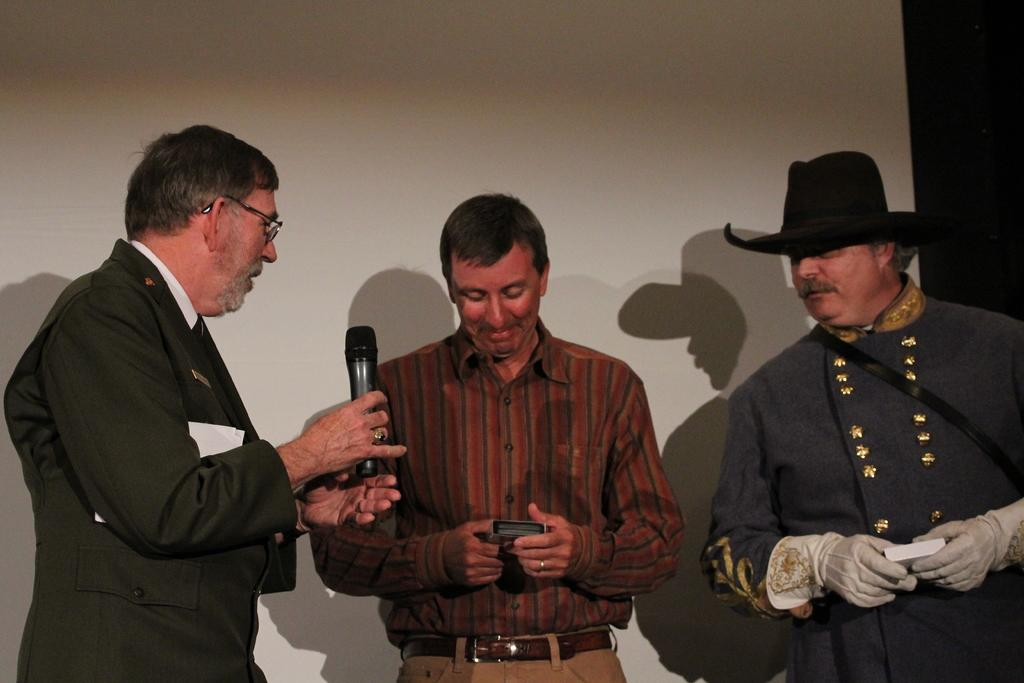How many people are in the image? There are three persons standing in the image. What is the person on the left holding? One person is holding a paper and a microphone. What are the other two persons holding? Two persons are holding objects. Can you describe the clothing of one of the persons? One person is wearing a cap. What is visible in the background of the image? There is a wall in the background of the image. What type of stem can be seen growing from the rabbit's ear in the image? There is no rabbit present in the image, so there is no stem growing from its ear. 